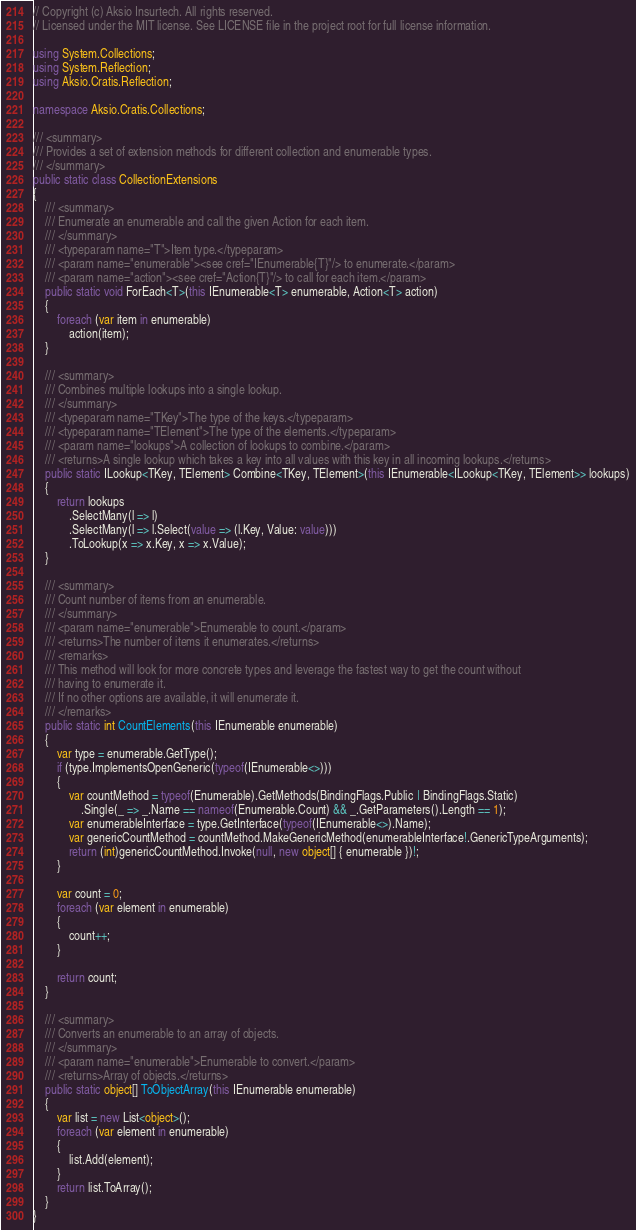Convert code to text. <code><loc_0><loc_0><loc_500><loc_500><_C#_>// Copyright (c) Aksio Insurtech. All rights reserved.
// Licensed under the MIT license. See LICENSE file in the project root for full license information.

using System.Collections;
using System.Reflection;
using Aksio.Cratis.Reflection;

namespace Aksio.Cratis.Collections;

/// <summary>
/// Provides a set of extension methods for different collection and enumerable types.
/// </summary>
public static class CollectionExtensions
{
    /// <summary>
    /// Enumerate an enumerable and call the given Action for each item.
    /// </summary>
    /// <typeparam name="T">Item type.</typeparam>
    /// <param name="enumerable"><see cref="IEnumerable{T}"/> to enumerate.</param>
    /// <param name="action"><see cref="Action{T}"/> to call for each item.</param>
    public static void ForEach<T>(this IEnumerable<T> enumerable, Action<T> action)
    {
        foreach (var item in enumerable)
            action(item);
    }

    /// <summary>
    /// Combines multiple lookups into a single lookup.
    /// </summary>
    /// <typeparam name="TKey">The type of the keys.</typeparam>
    /// <typeparam name="TElement">The type of the elements.</typeparam>
    /// <param name="lookups">A collection of lookups to combine.</param>
    /// <returns>A single lookup which takes a key into all values with this key in all incoming lookups.</returns>
    public static ILookup<TKey, TElement> Combine<TKey, TElement>(this IEnumerable<ILookup<TKey, TElement>> lookups)
    {
        return lookups
            .SelectMany(l => l)
            .SelectMany(l => l.Select(value => (l.Key, Value: value)))
            .ToLookup(x => x.Key, x => x.Value);
    }

    /// <summary>
    /// Count number of items from an enumerable.
    /// </summary>
    /// <param name="enumerable">Enumerable to count.</param>
    /// <returns>The number of items it enumerates.</returns>
    /// <remarks>
    /// This method will look for more concrete types and leverage the fastest way to get the count without
    /// having to enumerate it.
    /// If no other options are available, it will enumerate it.
    /// </remarks>
    public static int CountElements(this IEnumerable enumerable)
    {
        var type = enumerable.GetType();
        if (type.ImplementsOpenGeneric(typeof(IEnumerable<>)))
        {
            var countMethod = typeof(Enumerable).GetMethods(BindingFlags.Public | BindingFlags.Static)
                .Single(_ => _.Name == nameof(Enumerable.Count) && _.GetParameters().Length == 1);
            var enumerableInterface = type.GetInterface(typeof(IEnumerable<>).Name);
            var genericCountMethod = countMethod.MakeGenericMethod(enumerableInterface!.GenericTypeArguments);
            return (int)genericCountMethod.Invoke(null, new object[] { enumerable })!;
        }

        var count = 0;
        foreach (var element in enumerable)
        {
            count++;
        }

        return count;
    }

    /// <summary>
    /// Converts an enumerable to an array of objects.
    /// </summary>
    /// <param name="enumerable">Enumerable to convert.</param>
    /// <returns>Array of objects.</returns>
    public static object[] ToObjectArray(this IEnumerable enumerable)
    {
        var list = new List<object>();
        foreach (var element in enumerable)
        {
            list.Add(element);
        }
        return list.ToArray();
    }
}
</code> 